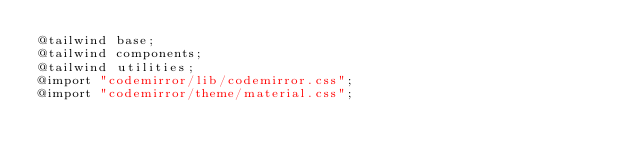Convert code to text. <code><loc_0><loc_0><loc_500><loc_500><_CSS_>@tailwind base;
@tailwind components;
@tailwind utilities;
@import "codemirror/lib/codemirror.css";
@import "codemirror/theme/material.css";
</code> 